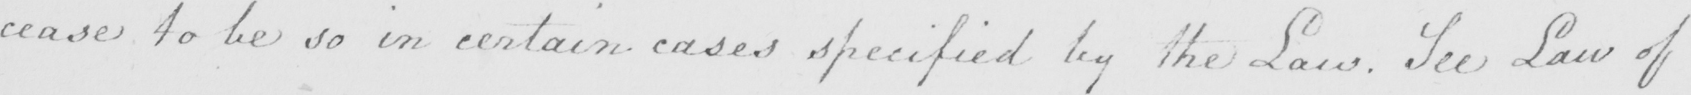What does this handwritten line say? cease to be so in certain cases specified by the Law . See Law of 